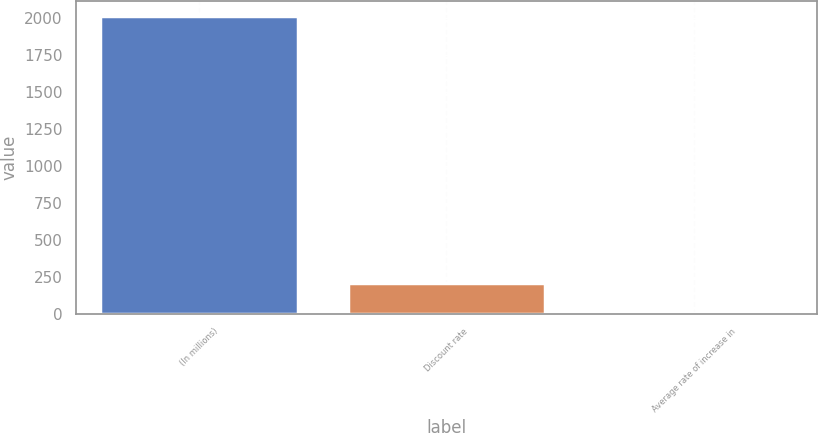Convert chart. <chart><loc_0><loc_0><loc_500><loc_500><bar_chart><fcel>(In millions)<fcel>Discount rate<fcel>Average rate of increase in<nl><fcel>2010<fcel>204.01<fcel>3.34<nl></chart> 